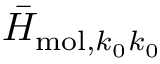<formula> <loc_0><loc_0><loc_500><loc_500>{ \bar { H } } _ { m o l , k _ { 0 } k _ { 0 } }</formula> 